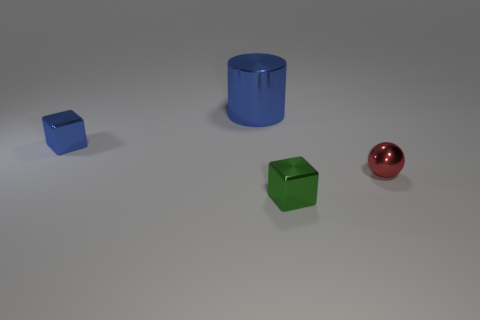What is the color of the sphere that is on the right side of the small shiny cube that is on the left side of the green shiny thing? The sphere located to the right of the small blue shiny cube, which in turn is to the left of the green shiny cube, is red in color. It displays a high-gloss surface, reflecting the environment, and on close observation, one can notice subtle highlights and shadows that enhance its spherical shape. 